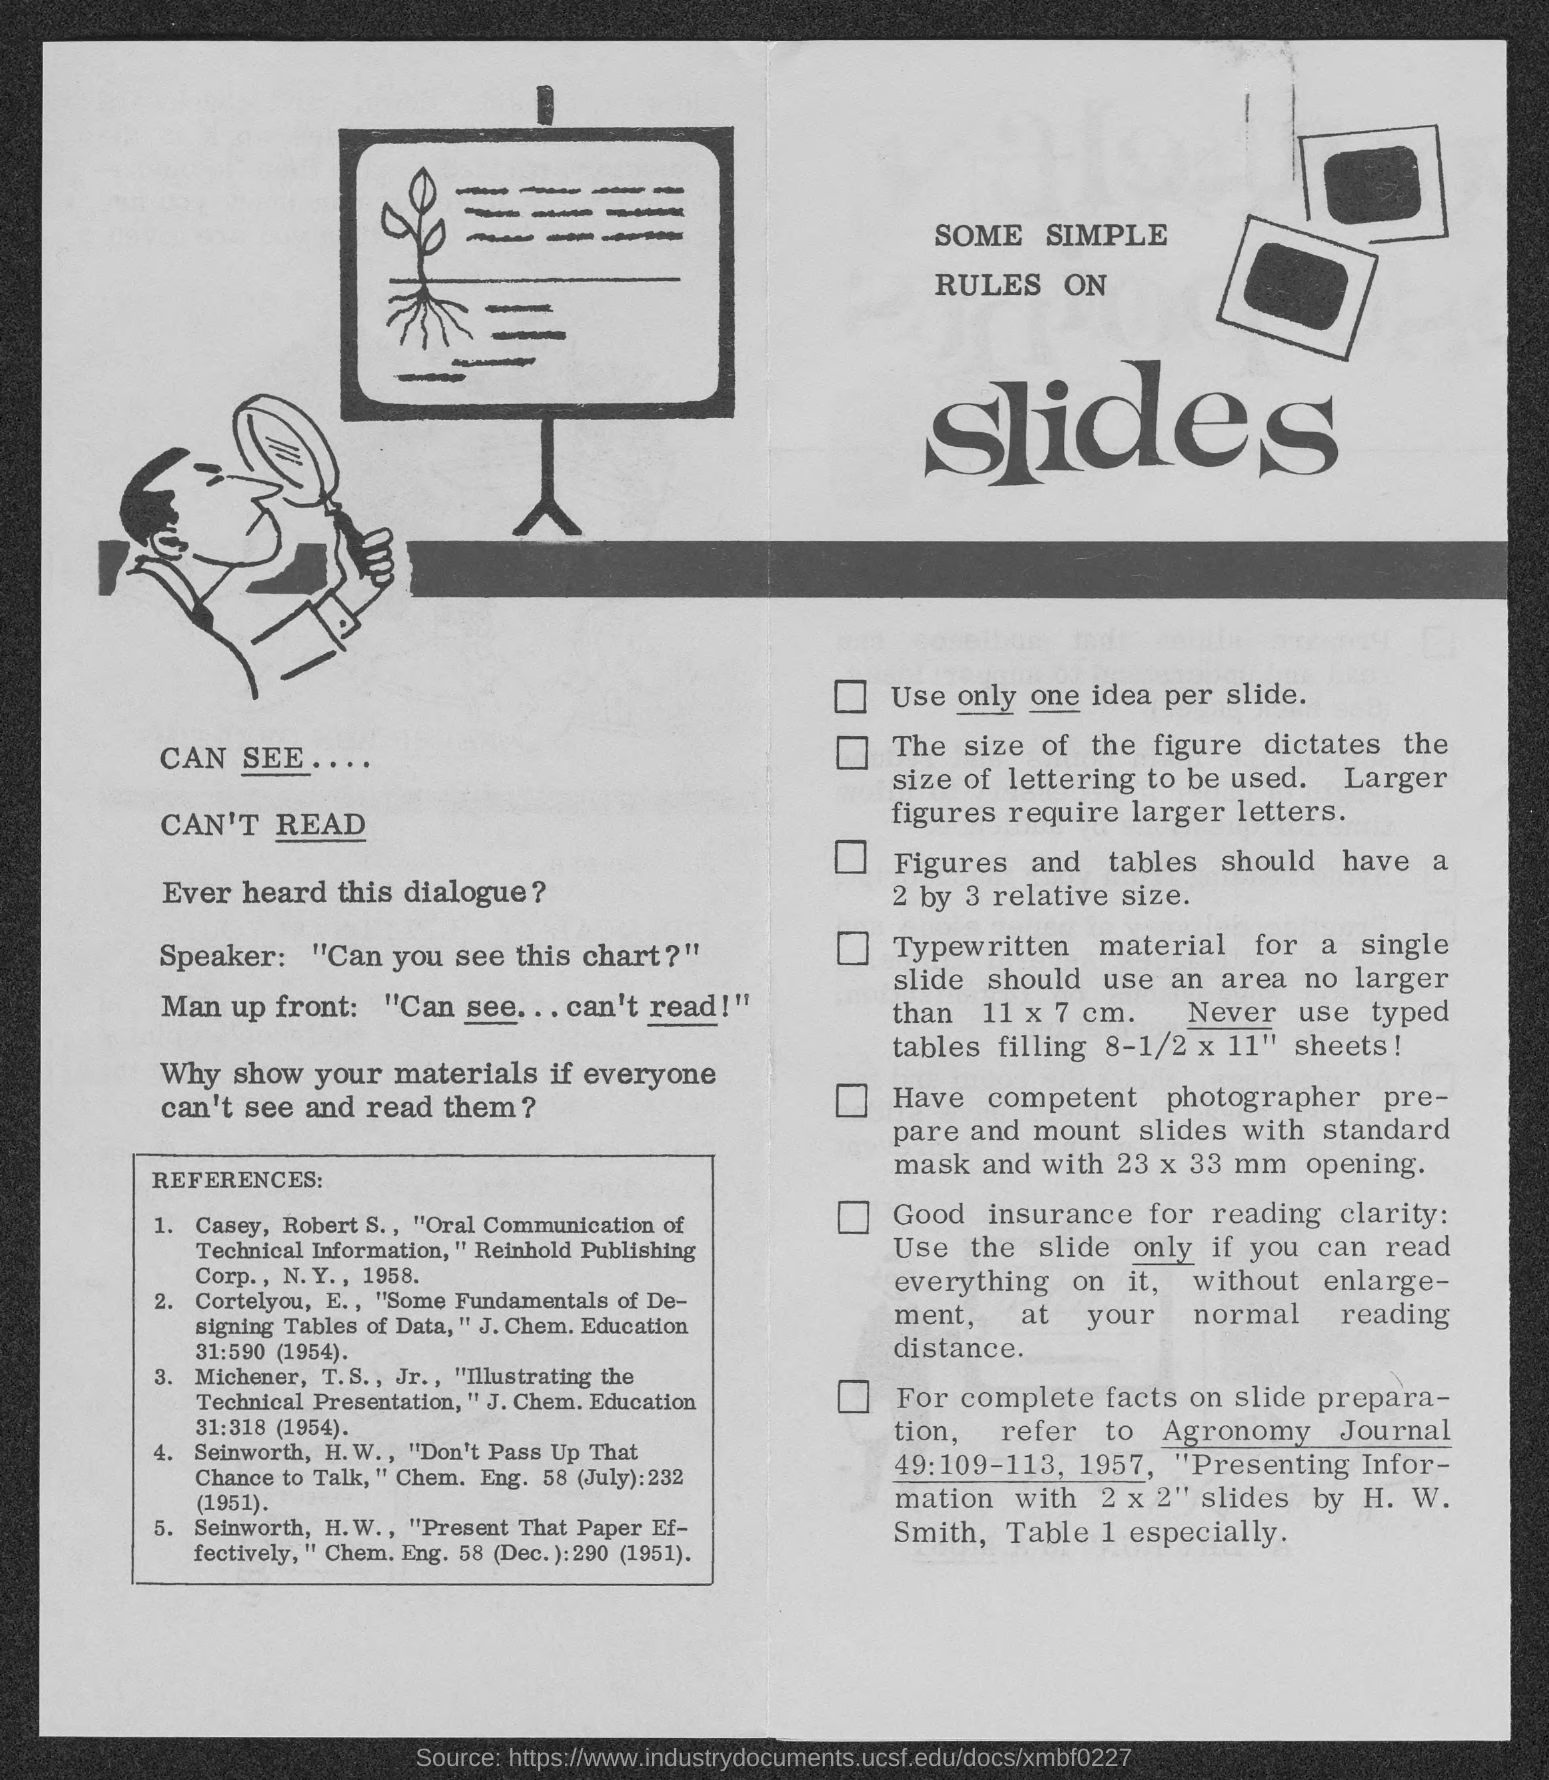What is the Title of the document?
Keep it short and to the point. Some simple rules on slides. 